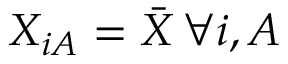<formula> <loc_0><loc_0><loc_500><loc_500>X _ { i A } = \bar { X } \, \forall i , A</formula> 